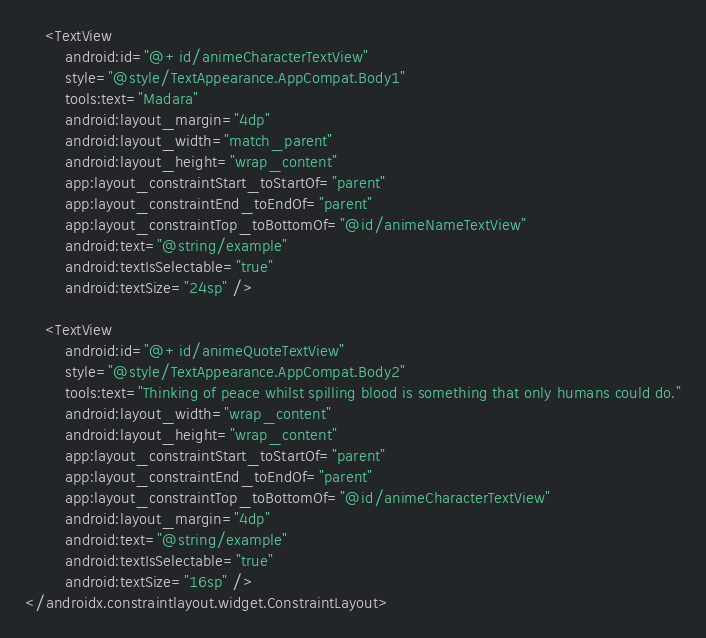<code> <loc_0><loc_0><loc_500><loc_500><_XML_>    <TextView
        android:id="@+id/animeCharacterTextView"
        style="@style/TextAppearance.AppCompat.Body1"
        tools:text="Madara"
        android:layout_margin="4dp"
        android:layout_width="match_parent"
        android:layout_height="wrap_content"
        app:layout_constraintStart_toStartOf="parent"
        app:layout_constraintEnd_toEndOf="parent"
        app:layout_constraintTop_toBottomOf="@id/animeNameTextView"
        android:text="@string/example"
        android:textIsSelectable="true"
        android:textSize="24sp" />

    <TextView
        android:id="@+id/animeQuoteTextView"
        style="@style/TextAppearance.AppCompat.Body2"
        tools:text="Thinking of peace whilst spilling blood is something that only humans could do."
        android:layout_width="wrap_content"
        android:layout_height="wrap_content"
        app:layout_constraintStart_toStartOf="parent"
        app:layout_constraintEnd_toEndOf="parent"
        app:layout_constraintTop_toBottomOf="@id/animeCharacterTextView"
        android:layout_margin="4dp"
        android:text="@string/example"
        android:textIsSelectable="true"
        android:textSize="16sp" />
</androidx.constraintlayout.widget.ConstraintLayout>




</code> 